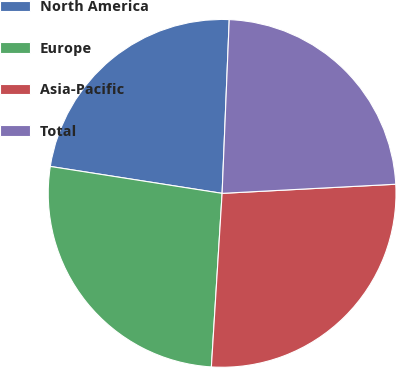<chart> <loc_0><loc_0><loc_500><loc_500><pie_chart><fcel>North America<fcel>Europe<fcel>Asia-Pacific<fcel>Total<nl><fcel>23.18%<fcel>26.49%<fcel>26.82%<fcel>23.51%<nl></chart> 